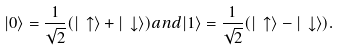Convert formula to latex. <formula><loc_0><loc_0><loc_500><loc_500>| 0 \rangle = \frac { 1 } { \sqrt { 2 } } ( | \, \uparrow \rangle + | \, \downarrow \rangle ) a n d | 1 \rangle = \frac { 1 } { \sqrt { 2 } } ( | \, \uparrow \rangle - | \, \downarrow \rangle ) .</formula> 